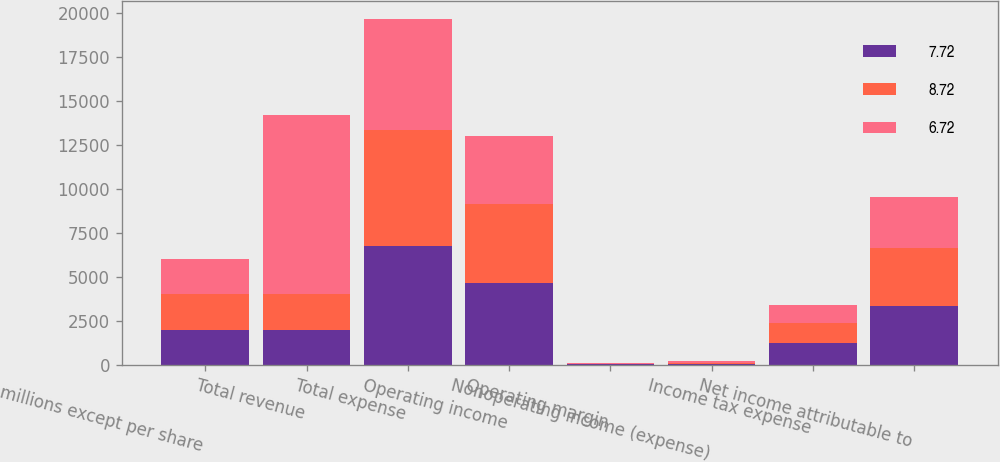Convert chart to OTSL. <chart><loc_0><loc_0><loc_500><loc_500><stacked_bar_chart><ecel><fcel>(in millions except per share<fcel>Total revenue<fcel>Total expense<fcel>Operating income<fcel>Operating margin<fcel>Nonoperating income (expense)<fcel>Income tax expense<fcel>Net income attributable to<nl><fcel>7.72<fcel>2015<fcel>2014.5<fcel>6737<fcel>4664<fcel>40.9<fcel>69<fcel>1250<fcel>3345<nl><fcel>8.72<fcel>2014<fcel>2014.5<fcel>6607<fcel>4474<fcel>40.4<fcel>49<fcel>1131<fcel>3294<nl><fcel>6.72<fcel>2013<fcel>10180<fcel>6323<fcel>3857<fcel>37.9<fcel>97<fcel>1022<fcel>2932<nl></chart> 